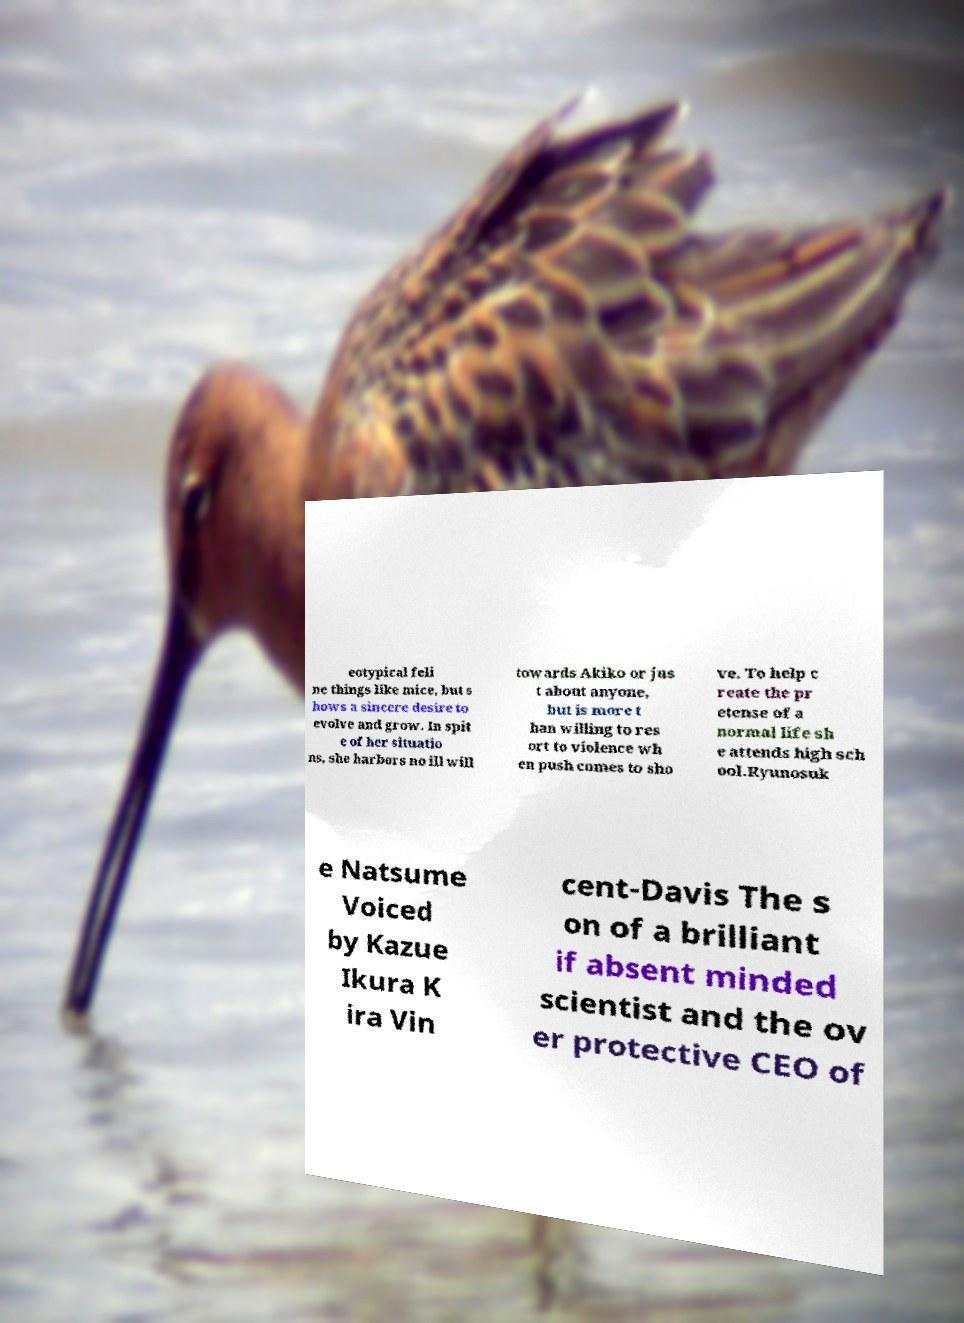For documentation purposes, I need the text within this image transcribed. Could you provide that? eotypical feli ne things like mice, but s hows a sincere desire to evolve and grow. In spit e of her situatio ns, she harbors no ill will towards Akiko or jus t about anyone, but is more t han willing to res ort to violence wh en push comes to sho ve. To help c reate the pr etense of a normal life sh e attends high sch ool.Ryunosuk e Natsume Voiced by Kazue Ikura K ira Vin cent-Davis The s on of a brilliant if absent minded scientist and the ov er protective CEO of 